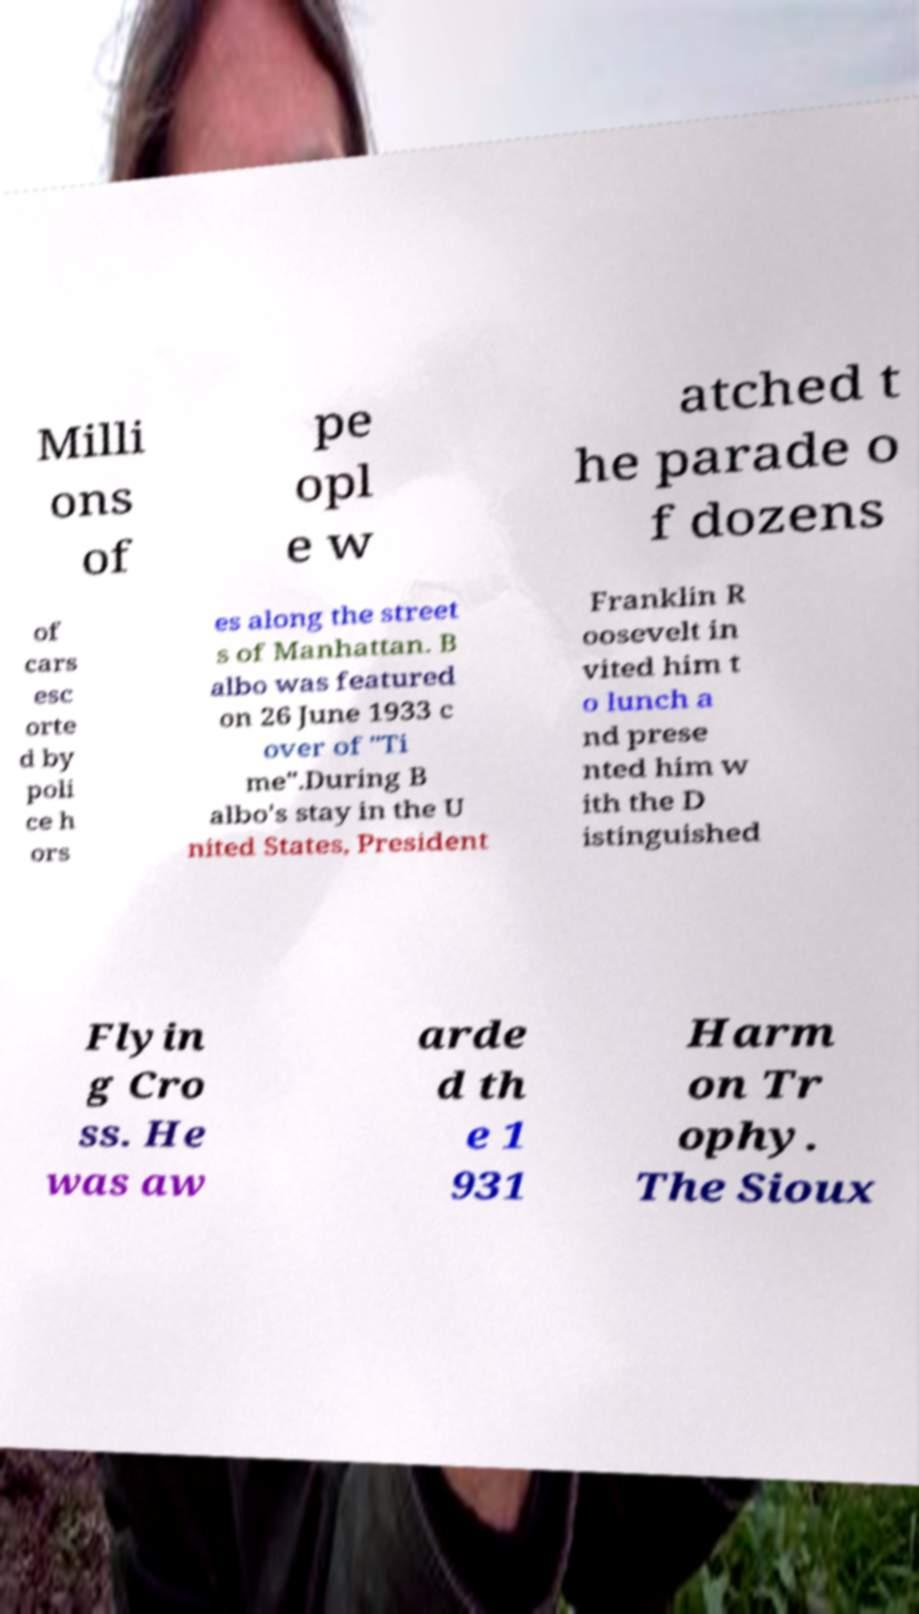I need the written content from this picture converted into text. Can you do that? Milli ons of pe opl e w atched t he parade o f dozens of cars esc orte d by poli ce h ors es along the street s of Manhattan. B albo was featured on 26 June 1933 c over of "Ti me".During B albo's stay in the U nited States, President Franklin R oosevelt in vited him t o lunch a nd prese nted him w ith the D istinguished Flyin g Cro ss. He was aw arde d th e 1 931 Harm on Tr ophy. The Sioux 